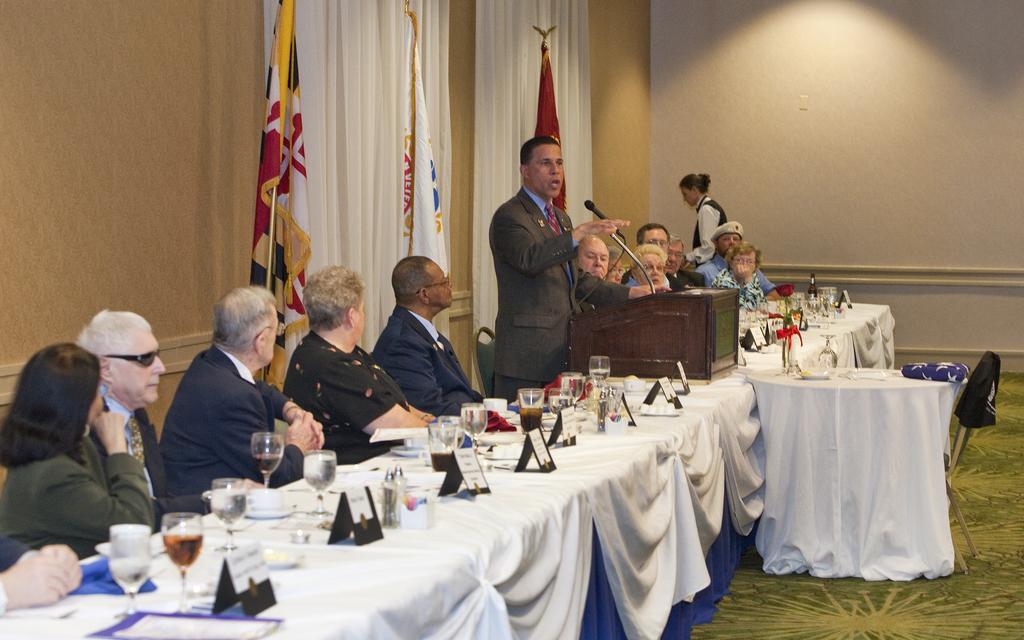Could you give a brief overview of what you see in this image? As we can see in the image there is a wall, curtains, flags, few people sitting on chairs and table. On table there are glasses, plates, bowls and papers. 